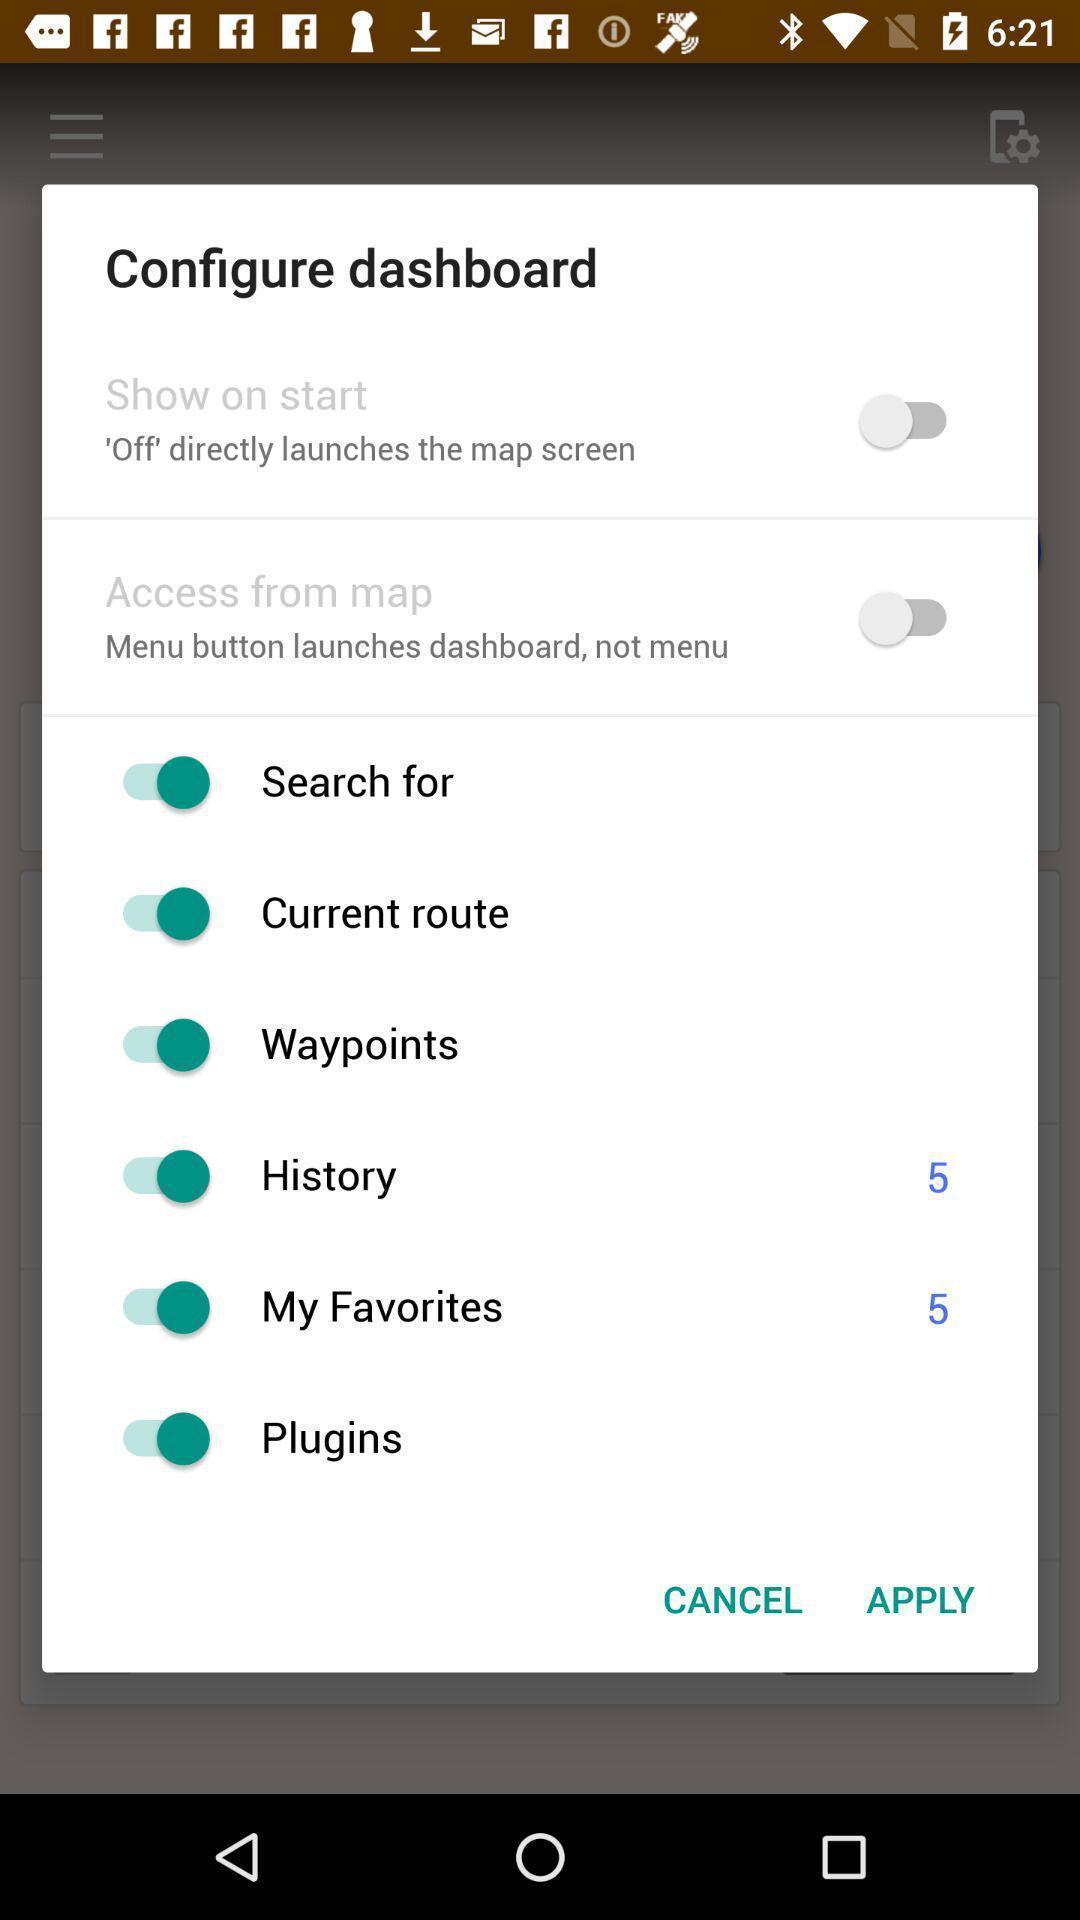Give me a narrative description of this picture. Push up displaying for configure dashboard. 